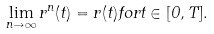<formula> <loc_0><loc_0><loc_500><loc_500>\lim _ { n \to \infty } r ^ { n } ( t ) = r ( t ) f o r t \in [ 0 , T ] .</formula> 